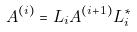Convert formula to latex. <formula><loc_0><loc_0><loc_500><loc_500>A ^ { ( i ) } = L _ { i } A ^ { ( i + 1 ) } L _ { i } ^ { * }</formula> 